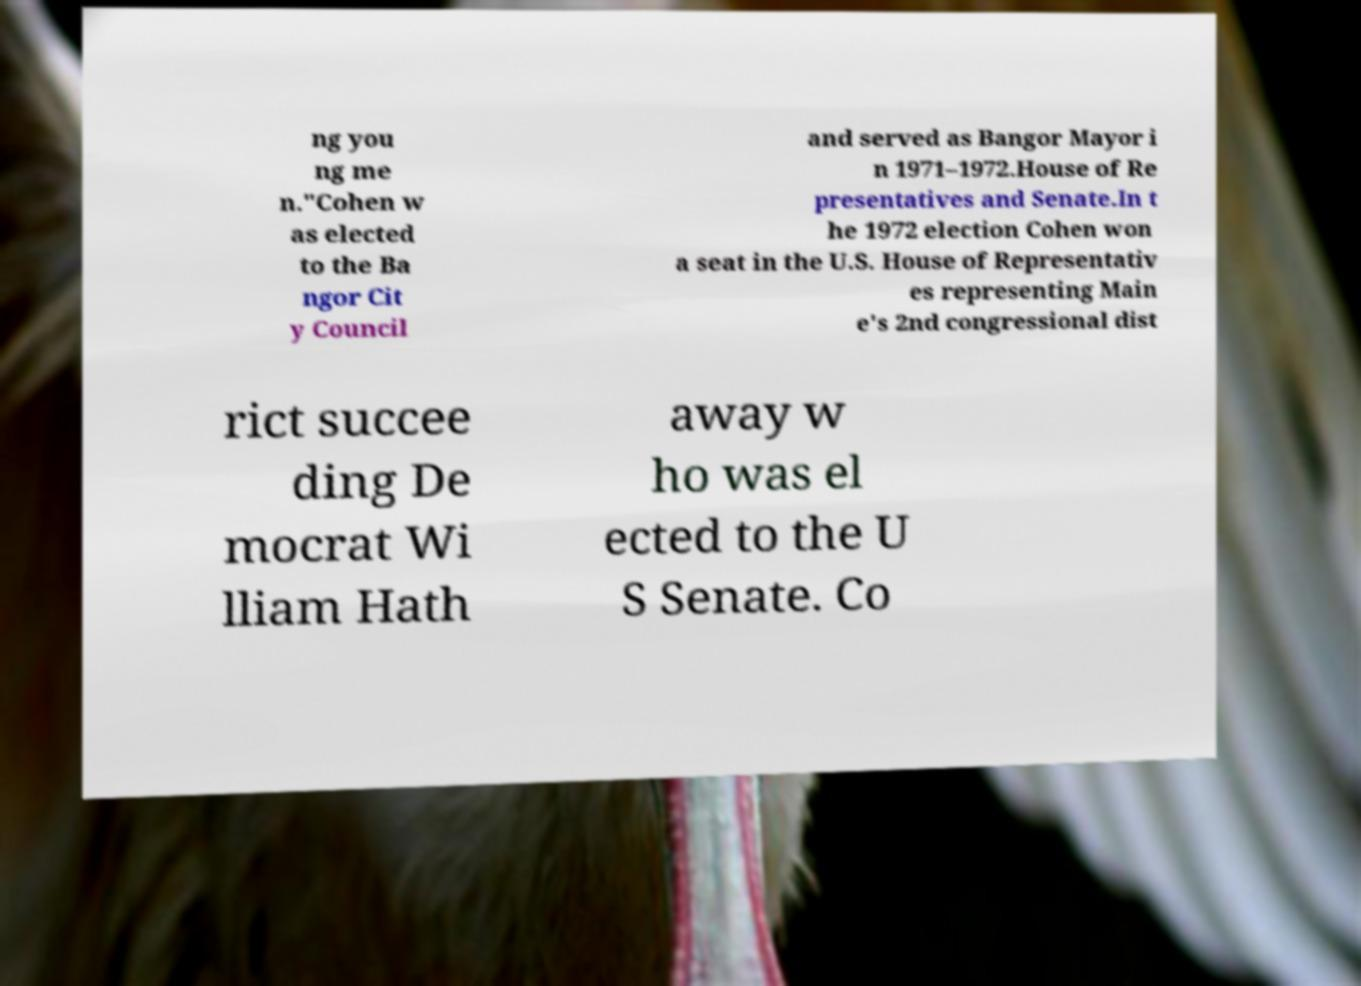Can you read and provide the text displayed in the image?This photo seems to have some interesting text. Can you extract and type it out for me? ng you ng me n."Cohen w as elected to the Ba ngor Cit y Council and served as Bangor Mayor i n 1971–1972.House of Re presentatives and Senate.In t he 1972 election Cohen won a seat in the U.S. House of Representativ es representing Main e's 2nd congressional dist rict succee ding De mocrat Wi lliam Hath away w ho was el ected to the U S Senate. Co 